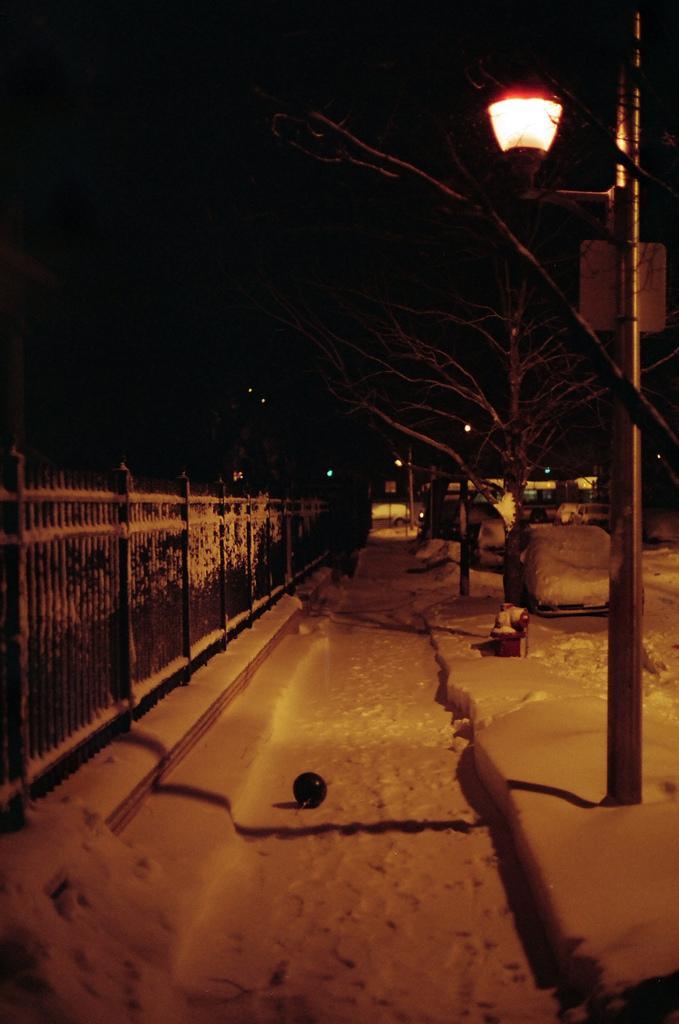How would you summarize this image in a sentence or two? In this image, I can see the snow. This looks like a street light. On the left side of the image, I can see iron grilles. These are the trees with branches. This looks like a vehicle, which is covered with the snow. 